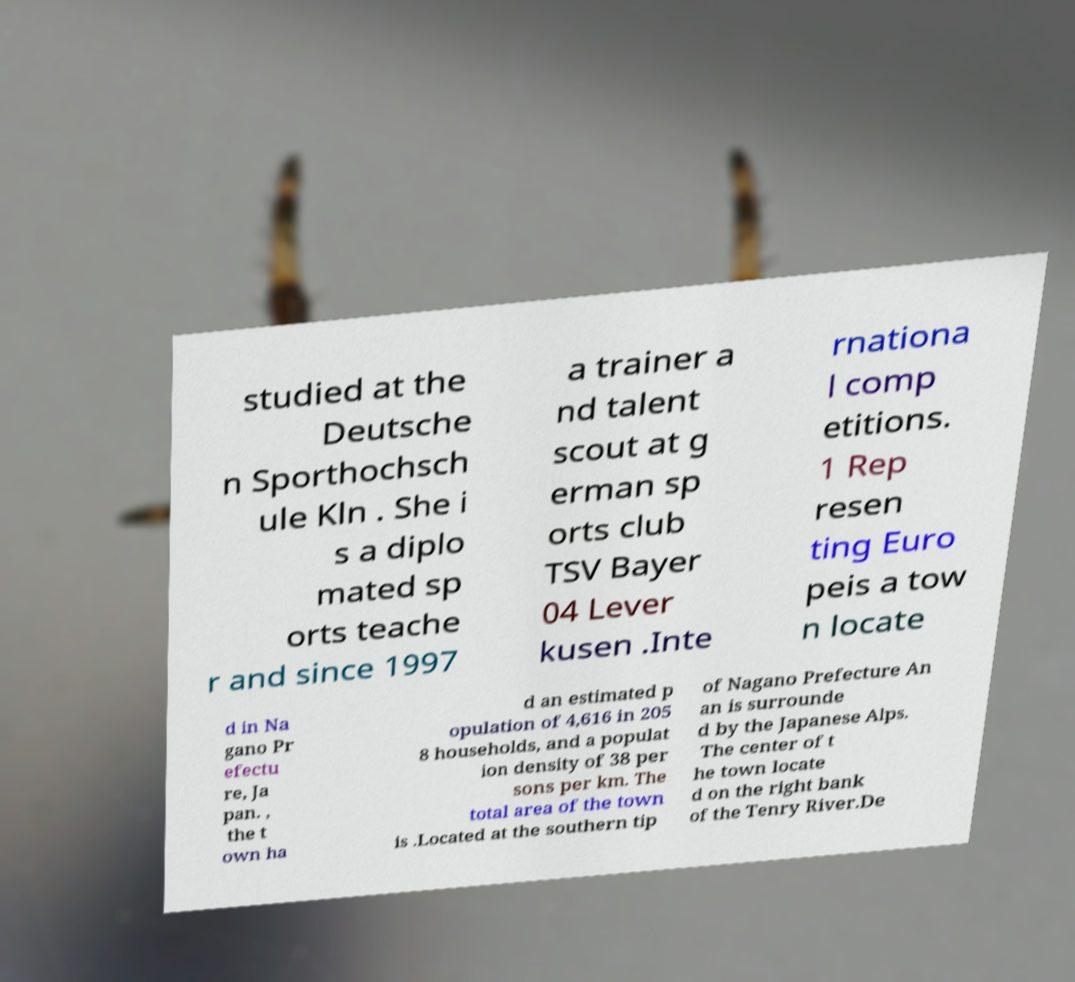Please read and relay the text visible in this image. What does it say? studied at the Deutsche n Sporthochsch ule Kln . She i s a diplo mated sp orts teache r and since 1997 a trainer a nd talent scout at g erman sp orts club TSV Bayer 04 Lever kusen .Inte rnationa l comp etitions. 1 Rep resen ting Euro peis a tow n locate d in Na gano Pr efectu re, Ja pan. , the t own ha d an estimated p opulation of 4,616 in 205 8 households, and a populat ion density of 38 per sons per km. The total area of the town is .Located at the southern tip of Nagano Prefecture An an is surrounde d by the Japanese Alps. The center of t he town locate d on the right bank of the Tenry River.De 